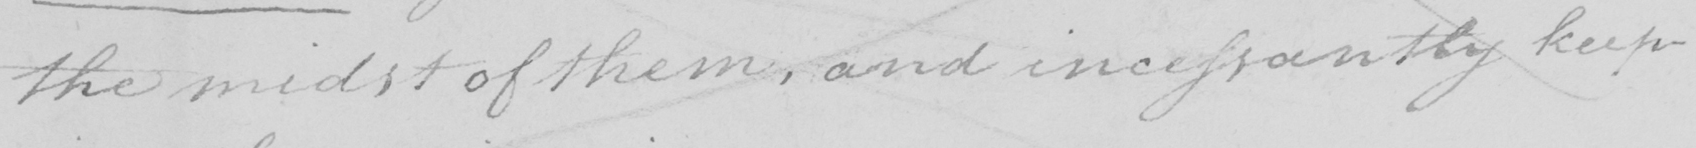Please transcribe the handwritten text in this image. the midst of them , and incessantly keep- 